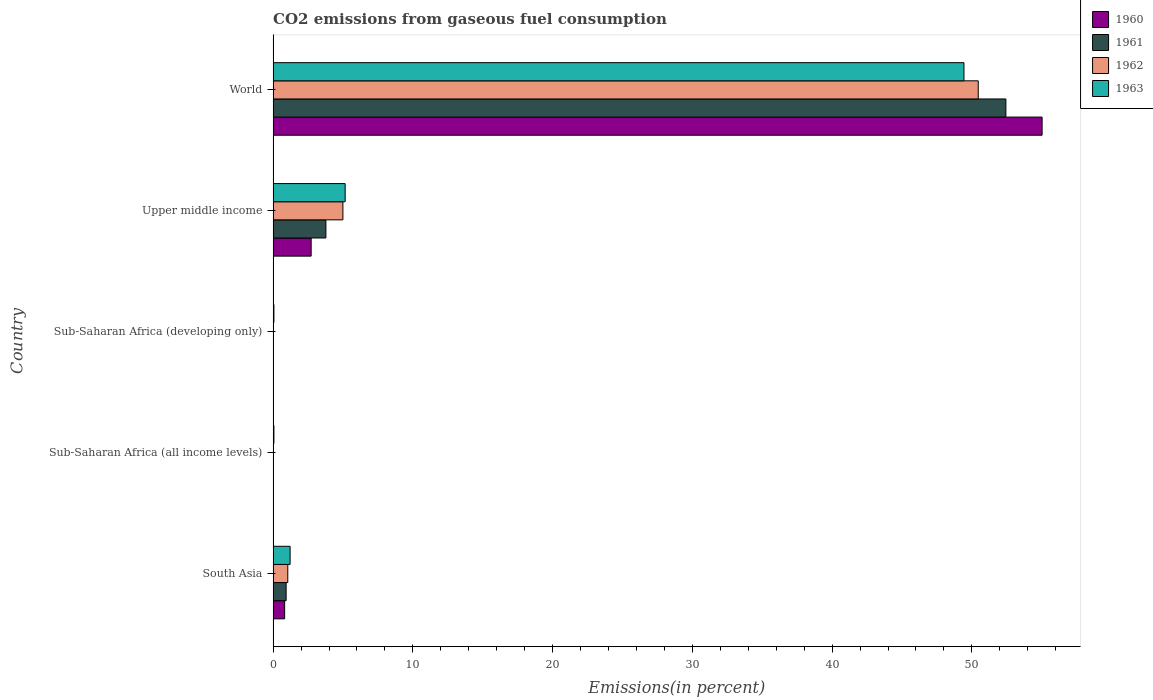Are the number of bars on each tick of the Y-axis equal?
Keep it short and to the point. Yes. How many bars are there on the 2nd tick from the top?
Your answer should be compact. 4. What is the label of the 4th group of bars from the top?
Give a very brief answer. Sub-Saharan Africa (all income levels). What is the total CO2 emitted in 1962 in Sub-Saharan Africa (developing only)?
Give a very brief answer. 0.01. Across all countries, what is the maximum total CO2 emitted in 1961?
Make the answer very short. 52.43. Across all countries, what is the minimum total CO2 emitted in 1961?
Your response must be concise. 0.01. In which country was the total CO2 emitted in 1963 maximum?
Provide a succinct answer. World. In which country was the total CO2 emitted in 1963 minimum?
Your answer should be very brief. Sub-Saharan Africa (all income levels). What is the total total CO2 emitted in 1963 in the graph?
Your response must be concise. 55.92. What is the difference between the total CO2 emitted in 1961 in South Asia and that in World?
Your answer should be compact. -51.5. What is the difference between the total CO2 emitted in 1960 in World and the total CO2 emitted in 1961 in Upper middle income?
Ensure brevity in your answer.  51.25. What is the average total CO2 emitted in 1961 per country?
Your answer should be very brief. 11.43. What is the difference between the total CO2 emitted in 1962 and total CO2 emitted in 1960 in World?
Keep it short and to the point. -4.57. In how many countries, is the total CO2 emitted in 1963 greater than 54 %?
Provide a succinct answer. 0. What is the ratio of the total CO2 emitted in 1961 in South Asia to that in Sub-Saharan Africa (developing only)?
Keep it short and to the point. 78.17. Is the total CO2 emitted in 1962 in South Asia less than that in Sub-Saharan Africa (all income levels)?
Ensure brevity in your answer.  No. Is the difference between the total CO2 emitted in 1962 in Sub-Saharan Africa (developing only) and Upper middle income greater than the difference between the total CO2 emitted in 1960 in Sub-Saharan Africa (developing only) and Upper middle income?
Keep it short and to the point. No. What is the difference between the highest and the second highest total CO2 emitted in 1963?
Keep it short and to the point. 44.28. What is the difference between the highest and the lowest total CO2 emitted in 1962?
Keep it short and to the point. 50.44. Is it the case that in every country, the sum of the total CO2 emitted in 1963 and total CO2 emitted in 1960 is greater than the sum of total CO2 emitted in 1962 and total CO2 emitted in 1961?
Provide a short and direct response. No. What does the 1st bar from the top in Sub-Saharan Africa (all income levels) represents?
Give a very brief answer. 1963. What does the 1st bar from the bottom in Upper middle income represents?
Offer a terse response. 1960. Is it the case that in every country, the sum of the total CO2 emitted in 1961 and total CO2 emitted in 1962 is greater than the total CO2 emitted in 1960?
Your answer should be compact. Yes. How many countries are there in the graph?
Offer a terse response. 5. What is the difference between two consecutive major ticks on the X-axis?
Your answer should be compact. 10. Does the graph contain any zero values?
Keep it short and to the point. No. What is the title of the graph?
Make the answer very short. CO2 emissions from gaseous fuel consumption. What is the label or title of the X-axis?
Offer a very short reply. Emissions(in percent). What is the label or title of the Y-axis?
Your answer should be compact. Country. What is the Emissions(in percent) in 1960 in South Asia?
Offer a terse response. 0.82. What is the Emissions(in percent) in 1961 in South Asia?
Your answer should be compact. 0.93. What is the Emissions(in percent) of 1962 in South Asia?
Your answer should be very brief. 1.05. What is the Emissions(in percent) of 1963 in South Asia?
Make the answer very short. 1.22. What is the Emissions(in percent) of 1960 in Sub-Saharan Africa (all income levels)?
Provide a short and direct response. 0.01. What is the Emissions(in percent) in 1961 in Sub-Saharan Africa (all income levels)?
Make the answer very short. 0.01. What is the Emissions(in percent) in 1962 in Sub-Saharan Africa (all income levels)?
Make the answer very short. 0.01. What is the Emissions(in percent) of 1963 in Sub-Saharan Africa (all income levels)?
Your response must be concise. 0.06. What is the Emissions(in percent) in 1960 in Sub-Saharan Africa (developing only)?
Keep it short and to the point. 0.01. What is the Emissions(in percent) in 1961 in Sub-Saharan Africa (developing only)?
Your answer should be very brief. 0.01. What is the Emissions(in percent) in 1962 in Sub-Saharan Africa (developing only)?
Make the answer very short. 0.01. What is the Emissions(in percent) of 1963 in Sub-Saharan Africa (developing only)?
Provide a short and direct response. 0.06. What is the Emissions(in percent) in 1960 in Upper middle income?
Provide a short and direct response. 2.72. What is the Emissions(in percent) of 1961 in Upper middle income?
Your answer should be compact. 3.78. What is the Emissions(in percent) in 1962 in Upper middle income?
Ensure brevity in your answer.  4.99. What is the Emissions(in percent) in 1963 in Upper middle income?
Offer a very short reply. 5.15. What is the Emissions(in percent) in 1960 in World?
Ensure brevity in your answer.  55.02. What is the Emissions(in percent) in 1961 in World?
Offer a terse response. 52.43. What is the Emissions(in percent) in 1962 in World?
Ensure brevity in your answer.  50.46. What is the Emissions(in percent) in 1963 in World?
Offer a terse response. 49.43. Across all countries, what is the maximum Emissions(in percent) of 1960?
Provide a short and direct response. 55.02. Across all countries, what is the maximum Emissions(in percent) in 1961?
Your answer should be very brief. 52.43. Across all countries, what is the maximum Emissions(in percent) of 1962?
Provide a short and direct response. 50.46. Across all countries, what is the maximum Emissions(in percent) in 1963?
Provide a short and direct response. 49.43. Across all countries, what is the minimum Emissions(in percent) of 1960?
Provide a short and direct response. 0.01. Across all countries, what is the minimum Emissions(in percent) of 1961?
Provide a short and direct response. 0.01. Across all countries, what is the minimum Emissions(in percent) of 1962?
Provide a short and direct response. 0.01. Across all countries, what is the minimum Emissions(in percent) of 1963?
Offer a very short reply. 0.06. What is the total Emissions(in percent) in 1960 in the graph?
Provide a succinct answer. 58.6. What is the total Emissions(in percent) of 1961 in the graph?
Give a very brief answer. 57.17. What is the total Emissions(in percent) in 1962 in the graph?
Provide a succinct answer. 56.53. What is the total Emissions(in percent) of 1963 in the graph?
Give a very brief answer. 55.92. What is the difference between the Emissions(in percent) in 1960 in South Asia and that in Sub-Saharan Africa (all income levels)?
Ensure brevity in your answer.  0.81. What is the difference between the Emissions(in percent) in 1961 in South Asia and that in Sub-Saharan Africa (all income levels)?
Offer a terse response. 0.92. What is the difference between the Emissions(in percent) of 1962 in South Asia and that in Sub-Saharan Africa (all income levels)?
Provide a succinct answer. 1.03. What is the difference between the Emissions(in percent) in 1963 in South Asia and that in Sub-Saharan Africa (all income levels)?
Keep it short and to the point. 1.16. What is the difference between the Emissions(in percent) in 1960 in South Asia and that in Sub-Saharan Africa (developing only)?
Ensure brevity in your answer.  0.81. What is the difference between the Emissions(in percent) of 1961 in South Asia and that in Sub-Saharan Africa (developing only)?
Give a very brief answer. 0.92. What is the difference between the Emissions(in percent) in 1962 in South Asia and that in Sub-Saharan Africa (developing only)?
Your response must be concise. 1.03. What is the difference between the Emissions(in percent) of 1963 in South Asia and that in Sub-Saharan Africa (developing only)?
Keep it short and to the point. 1.16. What is the difference between the Emissions(in percent) in 1960 in South Asia and that in Upper middle income?
Your answer should be very brief. -1.9. What is the difference between the Emissions(in percent) in 1961 in South Asia and that in Upper middle income?
Give a very brief answer. -2.85. What is the difference between the Emissions(in percent) of 1962 in South Asia and that in Upper middle income?
Give a very brief answer. -3.94. What is the difference between the Emissions(in percent) of 1963 in South Asia and that in Upper middle income?
Your response must be concise. -3.94. What is the difference between the Emissions(in percent) in 1960 in South Asia and that in World?
Your answer should be compact. -54.2. What is the difference between the Emissions(in percent) in 1961 in South Asia and that in World?
Your response must be concise. -51.5. What is the difference between the Emissions(in percent) of 1962 in South Asia and that in World?
Give a very brief answer. -49.41. What is the difference between the Emissions(in percent) in 1963 in South Asia and that in World?
Ensure brevity in your answer.  -48.22. What is the difference between the Emissions(in percent) of 1961 in Sub-Saharan Africa (all income levels) and that in Sub-Saharan Africa (developing only)?
Give a very brief answer. -0. What is the difference between the Emissions(in percent) of 1962 in Sub-Saharan Africa (all income levels) and that in Sub-Saharan Africa (developing only)?
Keep it short and to the point. -0. What is the difference between the Emissions(in percent) of 1963 in Sub-Saharan Africa (all income levels) and that in Sub-Saharan Africa (developing only)?
Keep it short and to the point. -0. What is the difference between the Emissions(in percent) of 1960 in Sub-Saharan Africa (all income levels) and that in Upper middle income?
Provide a succinct answer. -2.71. What is the difference between the Emissions(in percent) in 1961 in Sub-Saharan Africa (all income levels) and that in Upper middle income?
Give a very brief answer. -3.77. What is the difference between the Emissions(in percent) in 1962 in Sub-Saharan Africa (all income levels) and that in Upper middle income?
Provide a succinct answer. -4.98. What is the difference between the Emissions(in percent) of 1963 in Sub-Saharan Africa (all income levels) and that in Upper middle income?
Provide a succinct answer. -5.1. What is the difference between the Emissions(in percent) in 1960 in Sub-Saharan Africa (all income levels) and that in World?
Provide a succinct answer. -55.01. What is the difference between the Emissions(in percent) in 1961 in Sub-Saharan Africa (all income levels) and that in World?
Keep it short and to the point. -52.42. What is the difference between the Emissions(in percent) of 1962 in Sub-Saharan Africa (all income levels) and that in World?
Give a very brief answer. -50.44. What is the difference between the Emissions(in percent) of 1963 in Sub-Saharan Africa (all income levels) and that in World?
Make the answer very short. -49.38. What is the difference between the Emissions(in percent) of 1960 in Sub-Saharan Africa (developing only) and that in Upper middle income?
Your answer should be very brief. -2.71. What is the difference between the Emissions(in percent) in 1961 in Sub-Saharan Africa (developing only) and that in Upper middle income?
Make the answer very short. -3.77. What is the difference between the Emissions(in percent) in 1962 in Sub-Saharan Africa (developing only) and that in Upper middle income?
Your answer should be very brief. -4.98. What is the difference between the Emissions(in percent) in 1963 in Sub-Saharan Africa (developing only) and that in Upper middle income?
Your answer should be compact. -5.1. What is the difference between the Emissions(in percent) of 1960 in Sub-Saharan Africa (developing only) and that in World?
Make the answer very short. -55.01. What is the difference between the Emissions(in percent) of 1961 in Sub-Saharan Africa (developing only) and that in World?
Keep it short and to the point. -52.42. What is the difference between the Emissions(in percent) of 1962 in Sub-Saharan Africa (developing only) and that in World?
Your answer should be compact. -50.44. What is the difference between the Emissions(in percent) in 1963 in Sub-Saharan Africa (developing only) and that in World?
Provide a short and direct response. -49.38. What is the difference between the Emissions(in percent) of 1960 in Upper middle income and that in World?
Make the answer very short. -52.3. What is the difference between the Emissions(in percent) in 1961 in Upper middle income and that in World?
Provide a succinct answer. -48.66. What is the difference between the Emissions(in percent) of 1962 in Upper middle income and that in World?
Your response must be concise. -45.46. What is the difference between the Emissions(in percent) in 1963 in Upper middle income and that in World?
Provide a short and direct response. -44.28. What is the difference between the Emissions(in percent) of 1960 in South Asia and the Emissions(in percent) of 1961 in Sub-Saharan Africa (all income levels)?
Your answer should be very brief. 0.81. What is the difference between the Emissions(in percent) of 1960 in South Asia and the Emissions(in percent) of 1962 in Sub-Saharan Africa (all income levels)?
Give a very brief answer. 0.81. What is the difference between the Emissions(in percent) of 1960 in South Asia and the Emissions(in percent) of 1963 in Sub-Saharan Africa (all income levels)?
Offer a very short reply. 0.77. What is the difference between the Emissions(in percent) in 1961 in South Asia and the Emissions(in percent) in 1962 in Sub-Saharan Africa (all income levels)?
Provide a short and direct response. 0.92. What is the difference between the Emissions(in percent) in 1961 in South Asia and the Emissions(in percent) in 1963 in Sub-Saharan Africa (all income levels)?
Give a very brief answer. 0.87. What is the difference between the Emissions(in percent) in 1962 in South Asia and the Emissions(in percent) in 1963 in Sub-Saharan Africa (all income levels)?
Offer a terse response. 0.99. What is the difference between the Emissions(in percent) of 1960 in South Asia and the Emissions(in percent) of 1961 in Sub-Saharan Africa (developing only)?
Keep it short and to the point. 0.81. What is the difference between the Emissions(in percent) in 1960 in South Asia and the Emissions(in percent) in 1962 in Sub-Saharan Africa (developing only)?
Keep it short and to the point. 0.81. What is the difference between the Emissions(in percent) of 1960 in South Asia and the Emissions(in percent) of 1963 in Sub-Saharan Africa (developing only)?
Ensure brevity in your answer.  0.77. What is the difference between the Emissions(in percent) of 1961 in South Asia and the Emissions(in percent) of 1962 in Sub-Saharan Africa (developing only)?
Offer a very short reply. 0.92. What is the difference between the Emissions(in percent) of 1961 in South Asia and the Emissions(in percent) of 1963 in Sub-Saharan Africa (developing only)?
Ensure brevity in your answer.  0.87. What is the difference between the Emissions(in percent) of 1960 in South Asia and the Emissions(in percent) of 1961 in Upper middle income?
Offer a very short reply. -2.95. What is the difference between the Emissions(in percent) in 1960 in South Asia and the Emissions(in percent) in 1962 in Upper middle income?
Provide a succinct answer. -4.17. What is the difference between the Emissions(in percent) of 1960 in South Asia and the Emissions(in percent) of 1963 in Upper middle income?
Give a very brief answer. -4.33. What is the difference between the Emissions(in percent) in 1961 in South Asia and the Emissions(in percent) in 1962 in Upper middle income?
Offer a terse response. -4.06. What is the difference between the Emissions(in percent) in 1961 in South Asia and the Emissions(in percent) in 1963 in Upper middle income?
Provide a succinct answer. -4.22. What is the difference between the Emissions(in percent) of 1962 in South Asia and the Emissions(in percent) of 1963 in Upper middle income?
Ensure brevity in your answer.  -4.11. What is the difference between the Emissions(in percent) of 1960 in South Asia and the Emissions(in percent) of 1961 in World?
Your answer should be compact. -51.61. What is the difference between the Emissions(in percent) of 1960 in South Asia and the Emissions(in percent) of 1962 in World?
Give a very brief answer. -49.63. What is the difference between the Emissions(in percent) in 1960 in South Asia and the Emissions(in percent) in 1963 in World?
Give a very brief answer. -48.61. What is the difference between the Emissions(in percent) of 1961 in South Asia and the Emissions(in percent) of 1962 in World?
Offer a terse response. -49.52. What is the difference between the Emissions(in percent) of 1961 in South Asia and the Emissions(in percent) of 1963 in World?
Provide a succinct answer. -48.5. What is the difference between the Emissions(in percent) of 1962 in South Asia and the Emissions(in percent) of 1963 in World?
Keep it short and to the point. -48.38. What is the difference between the Emissions(in percent) in 1960 in Sub-Saharan Africa (all income levels) and the Emissions(in percent) in 1962 in Sub-Saharan Africa (developing only)?
Keep it short and to the point. -0. What is the difference between the Emissions(in percent) of 1960 in Sub-Saharan Africa (all income levels) and the Emissions(in percent) of 1963 in Sub-Saharan Africa (developing only)?
Your answer should be very brief. -0.05. What is the difference between the Emissions(in percent) of 1961 in Sub-Saharan Africa (all income levels) and the Emissions(in percent) of 1962 in Sub-Saharan Africa (developing only)?
Your response must be concise. -0. What is the difference between the Emissions(in percent) in 1961 in Sub-Saharan Africa (all income levels) and the Emissions(in percent) in 1963 in Sub-Saharan Africa (developing only)?
Offer a terse response. -0.05. What is the difference between the Emissions(in percent) in 1962 in Sub-Saharan Africa (all income levels) and the Emissions(in percent) in 1963 in Sub-Saharan Africa (developing only)?
Offer a terse response. -0.04. What is the difference between the Emissions(in percent) of 1960 in Sub-Saharan Africa (all income levels) and the Emissions(in percent) of 1961 in Upper middle income?
Provide a short and direct response. -3.77. What is the difference between the Emissions(in percent) in 1960 in Sub-Saharan Africa (all income levels) and the Emissions(in percent) in 1962 in Upper middle income?
Your answer should be compact. -4.98. What is the difference between the Emissions(in percent) in 1960 in Sub-Saharan Africa (all income levels) and the Emissions(in percent) in 1963 in Upper middle income?
Your answer should be very brief. -5.14. What is the difference between the Emissions(in percent) of 1961 in Sub-Saharan Africa (all income levels) and the Emissions(in percent) of 1962 in Upper middle income?
Keep it short and to the point. -4.98. What is the difference between the Emissions(in percent) of 1961 in Sub-Saharan Africa (all income levels) and the Emissions(in percent) of 1963 in Upper middle income?
Provide a succinct answer. -5.14. What is the difference between the Emissions(in percent) in 1962 in Sub-Saharan Africa (all income levels) and the Emissions(in percent) in 1963 in Upper middle income?
Make the answer very short. -5.14. What is the difference between the Emissions(in percent) of 1960 in Sub-Saharan Africa (all income levels) and the Emissions(in percent) of 1961 in World?
Offer a terse response. -52.42. What is the difference between the Emissions(in percent) of 1960 in Sub-Saharan Africa (all income levels) and the Emissions(in percent) of 1962 in World?
Offer a very short reply. -50.44. What is the difference between the Emissions(in percent) of 1960 in Sub-Saharan Africa (all income levels) and the Emissions(in percent) of 1963 in World?
Your answer should be very brief. -49.42. What is the difference between the Emissions(in percent) in 1961 in Sub-Saharan Africa (all income levels) and the Emissions(in percent) in 1962 in World?
Your answer should be very brief. -50.44. What is the difference between the Emissions(in percent) of 1961 in Sub-Saharan Africa (all income levels) and the Emissions(in percent) of 1963 in World?
Provide a short and direct response. -49.42. What is the difference between the Emissions(in percent) in 1962 in Sub-Saharan Africa (all income levels) and the Emissions(in percent) in 1963 in World?
Provide a succinct answer. -49.42. What is the difference between the Emissions(in percent) of 1960 in Sub-Saharan Africa (developing only) and the Emissions(in percent) of 1961 in Upper middle income?
Provide a short and direct response. -3.77. What is the difference between the Emissions(in percent) in 1960 in Sub-Saharan Africa (developing only) and the Emissions(in percent) in 1962 in Upper middle income?
Your answer should be compact. -4.98. What is the difference between the Emissions(in percent) in 1960 in Sub-Saharan Africa (developing only) and the Emissions(in percent) in 1963 in Upper middle income?
Offer a terse response. -5.14. What is the difference between the Emissions(in percent) in 1961 in Sub-Saharan Africa (developing only) and the Emissions(in percent) in 1962 in Upper middle income?
Your response must be concise. -4.98. What is the difference between the Emissions(in percent) of 1961 in Sub-Saharan Africa (developing only) and the Emissions(in percent) of 1963 in Upper middle income?
Offer a terse response. -5.14. What is the difference between the Emissions(in percent) in 1962 in Sub-Saharan Africa (developing only) and the Emissions(in percent) in 1963 in Upper middle income?
Provide a succinct answer. -5.14. What is the difference between the Emissions(in percent) of 1960 in Sub-Saharan Africa (developing only) and the Emissions(in percent) of 1961 in World?
Offer a very short reply. -52.42. What is the difference between the Emissions(in percent) of 1960 in Sub-Saharan Africa (developing only) and the Emissions(in percent) of 1962 in World?
Provide a short and direct response. -50.44. What is the difference between the Emissions(in percent) in 1960 in Sub-Saharan Africa (developing only) and the Emissions(in percent) in 1963 in World?
Your response must be concise. -49.42. What is the difference between the Emissions(in percent) of 1961 in Sub-Saharan Africa (developing only) and the Emissions(in percent) of 1962 in World?
Your response must be concise. -50.44. What is the difference between the Emissions(in percent) of 1961 in Sub-Saharan Africa (developing only) and the Emissions(in percent) of 1963 in World?
Provide a succinct answer. -49.42. What is the difference between the Emissions(in percent) of 1962 in Sub-Saharan Africa (developing only) and the Emissions(in percent) of 1963 in World?
Make the answer very short. -49.42. What is the difference between the Emissions(in percent) in 1960 in Upper middle income and the Emissions(in percent) in 1961 in World?
Give a very brief answer. -49.71. What is the difference between the Emissions(in percent) of 1960 in Upper middle income and the Emissions(in percent) of 1962 in World?
Make the answer very short. -47.73. What is the difference between the Emissions(in percent) of 1960 in Upper middle income and the Emissions(in percent) of 1963 in World?
Make the answer very short. -46.71. What is the difference between the Emissions(in percent) of 1961 in Upper middle income and the Emissions(in percent) of 1962 in World?
Your response must be concise. -46.68. What is the difference between the Emissions(in percent) in 1961 in Upper middle income and the Emissions(in percent) in 1963 in World?
Offer a very short reply. -45.66. What is the difference between the Emissions(in percent) in 1962 in Upper middle income and the Emissions(in percent) in 1963 in World?
Provide a short and direct response. -44.44. What is the average Emissions(in percent) in 1960 per country?
Provide a short and direct response. 11.72. What is the average Emissions(in percent) of 1961 per country?
Ensure brevity in your answer.  11.43. What is the average Emissions(in percent) of 1962 per country?
Offer a very short reply. 11.31. What is the average Emissions(in percent) of 1963 per country?
Your answer should be compact. 11.18. What is the difference between the Emissions(in percent) in 1960 and Emissions(in percent) in 1961 in South Asia?
Make the answer very short. -0.11. What is the difference between the Emissions(in percent) in 1960 and Emissions(in percent) in 1962 in South Asia?
Offer a terse response. -0.22. What is the difference between the Emissions(in percent) of 1960 and Emissions(in percent) of 1963 in South Asia?
Ensure brevity in your answer.  -0.39. What is the difference between the Emissions(in percent) of 1961 and Emissions(in percent) of 1962 in South Asia?
Provide a short and direct response. -0.12. What is the difference between the Emissions(in percent) of 1961 and Emissions(in percent) of 1963 in South Asia?
Provide a succinct answer. -0.28. What is the difference between the Emissions(in percent) in 1962 and Emissions(in percent) in 1963 in South Asia?
Provide a short and direct response. -0.17. What is the difference between the Emissions(in percent) in 1960 and Emissions(in percent) in 1962 in Sub-Saharan Africa (all income levels)?
Provide a succinct answer. -0. What is the difference between the Emissions(in percent) in 1960 and Emissions(in percent) in 1963 in Sub-Saharan Africa (all income levels)?
Your answer should be very brief. -0.05. What is the difference between the Emissions(in percent) in 1961 and Emissions(in percent) in 1962 in Sub-Saharan Africa (all income levels)?
Ensure brevity in your answer.  -0. What is the difference between the Emissions(in percent) in 1961 and Emissions(in percent) in 1963 in Sub-Saharan Africa (all income levels)?
Offer a very short reply. -0.05. What is the difference between the Emissions(in percent) in 1962 and Emissions(in percent) in 1963 in Sub-Saharan Africa (all income levels)?
Keep it short and to the point. -0.04. What is the difference between the Emissions(in percent) of 1960 and Emissions(in percent) of 1962 in Sub-Saharan Africa (developing only)?
Give a very brief answer. -0. What is the difference between the Emissions(in percent) in 1960 and Emissions(in percent) in 1963 in Sub-Saharan Africa (developing only)?
Offer a terse response. -0.05. What is the difference between the Emissions(in percent) of 1961 and Emissions(in percent) of 1962 in Sub-Saharan Africa (developing only)?
Provide a short and direct response. -0. What is the difference between the Emissions(in percent) in 1961 and Emissions(in percent) in 1963 in Sub-Saharan Africa (developing only)?
Provide a short and direct response. -0.05. What is the difference between the Emissions(in percent) of 1962 and Emissions(in percent) of 1963 in Sub-Saharan Africa (developing only)?
Offer a very short reply. -0.04. What is the difference between the Emissions(in percent) in 1960 and Emissions(in percent) in 1961 in Upper middle income?
Your response must be concise. -1.06. What is the difference between the Emissions(in percent) of 1960 and Emissions(in percent) of 1962 in Upper middle income?
Offer a very short reply. -2.27. What is the difference between the Emissions(in percent) of 1960 and Emissions(in percent) of 1963 in Upper middle income?
Your answer should be compact. -2.43. What is the difference between the Emissions(in percent) in 1961 and Emissions(in percent) in 1962 in Upper middle income?
Your answer should be very brief. -1.22. What is the difference between the Emissions(in percent) in 1961 and Emissions(in percent) in 1963 in Upper middle income?
Offer a terse response. -1.38. What is the difference between the Emissions(in percent) in 1962 and Emissions(in percent) in 1963 in Upper middle income?
Give a very brief answer. -0.16. What is the difference between the Emissions(in percent) of 1960 and Emissions(in percent) of 1961 in World?
Make the answer very short. 2.59. What is the difference between the Emissions(in percent) in 1960 and Emissions(in percent) in 1962 in World?
Keep it short and to the point. 4.57. What is the difference between the Emissions(in percent) in 1960 and Emissions(in percent) in 1963 in World?
Give a very brief answer. 5.59. What is the difference between the Emissions(in percent) in 1961 and Emissions(in percent) in 1962 in World?
Keep it short and to the point. 1.98. What is the difference between the Emissions(in percent) in 1961 and Emissions(in percent) in 1963 in World?
Provide a short and direct response. 3. What is the difference between the Emissions(in percent) of 1962 and Emissions(in percent) of 1963 in World?
Your answer should be very brief. 1.02. What is the ratio of the Emissions(in percent) of 1960 in South Asia to that in Sub-Saharan Africa (all income levels)?
Your answer should be very brief. 66.11. What is the ratio of the Emissions(in percent) in 1961 in South Asia to that in Sub-Saharan Africa (all income levels)?
Provide a succinct answer. 78.18. What is the ratio of the Emissions(in percent) of 1962 in South Asia to that in Sub-Saharan Africa (all income levels)?
Your answer should be very brief. 72.9. What is the ratio of the Emissions(in percent) in 1963 in South Asia to that in Sub-Saharan Africa (all income levels)?
Offer a very short reply. 21.08. What is the ratio of the Emissions(in percent) of 1960 in South Asia to that in Sub-Saharan Africa (developing only)?
Provide a short and direct response. 66.1. What is the ratio of the Emissions(in percent) in 1961 in South Asia to that in Sub-Saharan Africa (developing only)?
Make the answer very short. 78.17. What is the ratio of the Emissions(in percent) in 1962 in South Asia to that in Sub-Saharan Africa (developing only)?
Your answer should be very brief. 72.89. What is the ratio of the Emissions(in percent) in 1963 in South Asia to that in Sub-Saharan Africa (developing only)?
Your answer should be compact. 21.08. What is the ratio of the Emissions(in percent) in 1960 in South Asia to that in Upper middle income?
Provide a succinct answer. 0.3. What is the ratio of the Emissions(in percent) in 1961 in South Asia to that in Upper middle income?
Ensure brevity in your answer.  0.25. What is the ratio of the Emissions(in percent) of 1962 in South Asia to that in Upper middle income?
Ensure brevity in your answer.  0.21. What is the ratio of the Emissions(in percent) of 1963 in South Asia to that in Upper middle income?
Ensure brevity in your answer.  0.24. What is the ratio of the Emissions(in percent) in 1960 in South Asia to that in World?
Ensure brevity in your answer.  0.01. What is the ratio of the Emissions(in percent) in 1961 in South Asia to that in World?
Make the answer very short. 0.02. What is the ratio of the Emissions(in percent) of 1962 in South Asia to that in World?
Your answer should be very brief. 0.02. What is the ratio of the Emissions(in percent) in 1963 in South Asia to that in World?
Keep it short and to the point. 0.02. What is the ratio of the Emissions(in percent) in 1960 in Sub-Saharan Africa (all income levels) to that in Sub-Saharan Africa (developing only)?
Offer a terse response. 1. What is the ratio of the Emissions(in percent) in 1963 in Sub-Saharan Africa (all income levels) to that in Sub-Saharan Africa (developing only)?
Ensure brevity in your answer.  1. What is the ratio of the Emissions(in percent) of 1960 in Sub-Saharan Africa (all income levels) to that in Upper middle income?
Keep it short and to the point. 0. What is the ratio of the Emissions(in percent) in 1961 in Sub-Saharan Africa (all income levels) to that in Upper middle income?
Your response must be concise. 0. What is the ratio of the Emissions(in percent) in 1962 in Sub-Saharan Africa (all income levels) to that in Upper middle income?
Give a very brief answer. 0. What is the ratio of the Emissions(in percent) of 1963 in Sub-Saharan Africa (all income levels) to that in Upper middle income?
Your answer should be compact. 0.01. What is the ratio of the Emissions(in percent) in 1963 in Sub-Saharan Africa (all income levels) to that in World?
Provide a short and direct response. 0. What is the ratio of the Emissions(in percent) of 1960 in Sub-Saharan Africa (developing only) to that in Upper middle income?
Make the answer very short. 0. What is the ratio of the Emissions(in percent) in 1961 in Sub-Saharan Africa (developing only) to that in Upper middle income?
Give a very brief answer. 0. What is the ratio of the Emissions(in percent) in 1962 in Sub-Saharan Africa (developing only) to that in Upper middle income?
Your answer should be very brief. 0. What is the ratio of the Emissions(in percent) of 1963 in Sub-Saharan Africa (developing only) to that in Upper middle income?
Offer a terse response. 0.01. What is the ratio of the Emissions(in percent) in 1960 in Sub-Saharan Africa (developing only) to that in World?
Ensure brevity in your answer.  0. What is the ratio of the Emissions(in percent) of 1961 in Sub-Saharan Africa (developing only) to that in World?
Provide a short and direct response. 0. What is the ratio of the Emissions(in percent) of 1963 in Sub-Saharan Africa (developing only) to that in World?
Your response must be concise. 0. What is the ratio of the Emissions(in percent) of 1960 in Upper middle income to that in World?
Offer a very short reply. 0.05. What is the ratio of the Emissions(in percent) in 1961 in Upper middle income to that in World?
Your response must be concise. 0.07. What is the ratio of the Emissions(in percent) in 1962 in Upper middle income to that in World?
Your response must be concise. 0.1. What is the ratio of the Emissions(in percent) of 1963 in Upper middle income to that in World?
Your answer should be very brief. 0.1. What is the difference between the highest and the second highest Emissions(in percent) of 1960?
Ensure brevity in your answer.  52.3. What is the difference between the highest and the second highest Emissions(in percent) in 1961?
Offer a terse response. 48.66. What is the difference between the highest and the second highest Emissions(in percent) of 1962?
Your response must be concise. 45.46. What is the difference between the highest and the second highest Emissions(in percent) of 1963?
Give a very brief answer. 44.28. What is the difference between the highest and the lowest Emissions(in percent) in 1960?
Offer a terse response. 55.01. What is the difference between the highest and the lowest Emissions(in percent) of 1961?
Make the answer very short. 52.42. What is the difference between the highest and the lowest Emissions(in percent) of 1962?
Offer a terse response. 50.44. What is the difference between the highest and the lowest Emissions(in percent) of 1963?
Keep it short and to the point. 49.38. 